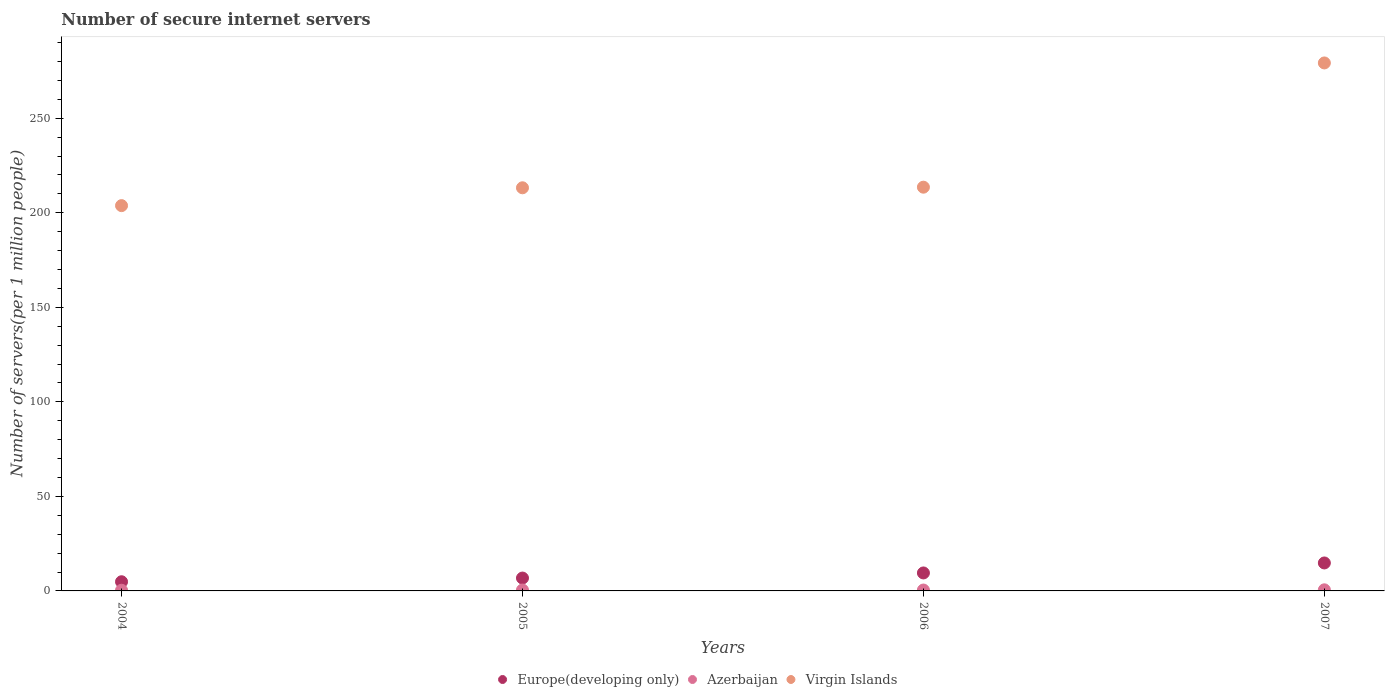How many different coloured dotlines are there?
Provide a succinct answer. 3. Is the number of dotlines equal to the number of legend labels?
Your answer should be very brief. Yes. What is the number of secure internet servers in Europe(developing only) in 2007?
Offer a very short reply. 14.79. Across all years, what is the maximum number of secure internet servers in Azerbaijan?
Keep it short and to the point. 0.58. Across all years, what is the minimum number of secure internet servers in Europe(developing only)?
Keep it short and to the point. 4.85. In which year was the number of secure internet servers in Azerbaijan minimum?
Give a very brief answer. 2004. What is the total number of secure internet servers in Virgin Islands in the graph?
Make the answer very short. 909.86. What is the difference between the number of secure internet servers in Virgin Islands in 2005 and that in 2007?
Ensure brevity in your answer.  -66.04. What is the difference between the number of secure internet servers in Europe(developing only) in 2006 and the number of secure internet servers in Virgin Islands in 2004?
Provide a succinct answer. -194.29. What is the average number of secure internet servers in Virgin Islands per year?
Your response must be concise. 227.46. In the year 2006, what is the difference between the number of secure internet servers in Azerbaijan and number of secure internet servers in Europe(developing only)?
Provide a succinct answer. -9.04. In how many years, is the number of secure internet servers in Europe(developing only) greater than 270?
Your response must be concise. 0. What is the ratio of the number of secure internet servers in Azerbaijan in 2005 to that in 2007?
Your response must be concise. 0.82. Is the number of secure internet servers in Europe(developing only) in 2004 less than that in 2007?
Make the answer very short. Yes. Is the difference between the number of secure internet servers in Azerbaijan in 2004 and 2005 greater than the difference between the number of secure internet servers in Europe(developing only) in 2004 and 2005?
Your answer should be compact. Yes. What is the difference between the highest and the second highest number of secure internet servers in Europe(developing only)?
Provide a short and direct response. 5.29. What is the difference between the highest and the lowest number of secure internet servers in Azerbaijan?
Make the answer very short. 0.22. In how many years, is the number of secure internet servers in Europe(developing only) greater than the average number of secure internet servers in Europe(developing only) taken over all years?
Offer a terse response. 2. Does the number of secure internet servers in Virgin Islands monotonically increase over the years?
Provide a succinct answer. Yes. Is the number of secure internet servers in Azerbaijan strictly greater than the number of secure internet servers in Europe(developing only) over the years?
Ensure brevity in your answer.  No. Is the number of secure internet servers in Azerbaijan strictly less than the number of secure internet servers in Virgin Islands over the years?
Make the answer very short. Yes. How many dotlines are there?
Your response must be concise. 3. Are the values on the major ticks of Y-axis written in scientific E-notation?
Your answer should be very brief. No. How are the legend labels stacked?
Ensure brevity in your answer.  Horizontal. What is the title of the graph?
Provide a succinct answer. Number of secure internet servers. What is the label or title of the Y-axis?
Make the answer very short. Number of servers(per 1 million people). What is the Number of servers(per 1 million people) in Europe(developing only) in 2004?
Your response must be concise. 4.85. What is the Number of servers(per 1 million people) of Azerbaijan in 2004?
Your response must be concise. 0.36. What is the Number of servers(per 1 million people) of Virgin Islands in 2004?
Offer a terse response. 203.8. What is the Number of servers(per 1 million people) in Europe(developing only) in 2005?
Your answer should be very brief. 6.8. What is the Number of servers(per 1 million people) of Azerbaijan in 2005?
Make the answer very short. 0.48. What is the Number of servers(per 1 million people) in Virgin Islands in 2005?
Your answer should be compact. 213.23. What is the Number of servers(per 1 million people) of Europe(developing only) in 2006?
Make the answer very short. 9.51. What is the Number of servers(per 1 million people) of Azerbaijan in 2006?
Give a very brief answer. 0.47. What is the Number of servers(per 1 million people) in Virgin Islands in 2006?
Make the answer very short. 213.56. What is the Number of servers(per 1 million people) of Europe(developing only) in 2007?
Give a very brief answer. 14.79. What is the Number of servers(per 1 million people) in Azerbaijan in 2007?
Your answer should be compact. 0.58. What is the Number of servers(per 1 million people) in Virgin Islands in 2007?
Make the answer very short. 279.27. Across all years, what is the maximum Number of servers(per 1 million people) of Europe(developing only)?
Your answer should be very brief. 14.79. Across all years, what is the maximum Number of servers(per 1 million people) of Azerbaijan?
Make the answer very short. 0.58. Across all years, what is the maximum Number of servers(per 1 million people) in Virgin Islands?
Make the answer very short. 279.27. Across all years, what is the minimum Number of servers(per 1 million people) in Europe(developing only)?
Provide a short and direct response. 4.85. Across all years, what is the minimum Number of servers(per 1 million people) in Azerbaijan?
Your response must be concise. 0.36. Across all years, what is the minimum Number of servers(per 1 million people) in Virgin Islands?
Your answer should be compact. 203.8. What is the total Number of servers(per 1 million people) of Europe(developing only) in the graph?
Make the answer very short. 35.96. What is the total Number of servers(per 1 million people) of Azerbaijan in the graph?
Your answer should be very brief. 1.89. What is the total Number of servers(per 1 million people) of Virgin Islands in the graph?
Provide a short and direct response. 909.86. What is the difference between the Number of servers(per 1 million people) of Europe(developing only) in 2004 and that in 2005?
Offer a very short reply. -1.95. What is the difference between the Number of servers(per 1 million people) in Azerbaijan in 2004 and that in 2005?
Give a very brief answer. -0.12. What is the difference between the Number of servers(per 1 million people) in Virgin Islands in 2004 and that in 2005?
Give a very brief answer. -9.44. What is the difference between the Number of servers(per 1 million people) in Europe(developing only) in 2004 and that in 2006?
Provide a short and direct response. -4.66. What is the difference between the Number of servers(per 1 million people) of Azerbaijan in 2004 and that in 2006?
Provide a succinct answer. -0.11. What is the difference between the Number of servers(per 1 million people) in Virgin Islands in 2004 and that in 2006?
Your response must be concise. -9.76. What is the difference between the Number of servers(per 1 million people) in Europe(developing only) in 2004 and that in 2007?
Offer a very short reply. -9.94. What is the difference between the Number of servers(per 1 million people) in Azerbaijan in 2004 and that in 2007?
Give a very brief answer. -0.22. What is the difference between the Number of servers(per 1 million people) of Virgin Islands in 2004 and that in 2007?
Offer a terse response. -75.47. What is the difference between the Number of servers(per 1 million people) of Europe(developing only) in 2005 and that in 2006?
Give a very brief answer. -2.7. What is the difference between the Number of servers(per 1 million people) in Azerbaijan in 2005 and that in 2006?
Make the answer very short. 0.01. What is the difference between the Number of servers(per 1 million people) of Virgin Islands in 2005 and that in 2006?
Ensure brevity in your answer.  -0.32. What is the difference between the Number of servers(per 1 million people) in Europe(developing only) in 2005 and that in 2007?
Offer a very short reply. -7.99. What is the difference between the Number of servers(per 1 million people) of Azerbaijan in 2005 and that in 2007?
Keep it short and to the point. -0.11. What is the difference between the Number of servers(per 1 million people) of Virgin Islands in 2005 and that in 2007?
Your response must be concise. -66.04. What is the difference between the Number of servers(per 1 million people) of Europe(developing only) in 2006 and that in 2007?
Your answer should be compact. -5.29. What is the difference between the Number of servers(per 1 million people) of Azerbaijan in 2006 and that in 2007?
Your answer should be very brief. -0.11. What is the difference between the Number of servers(per 1 million people) of Virgin Islands in 2006 and that in 2007?
Your response must be concise. -65.71. What is the difference between the Number of servers(per 1 million people) in Europe(developing only) in 2004 and the Number of servers(per 1 million people) in Azerbaijan in 2005?
Give a very brief answer. 4.38. What is the difference between the Number of servers(per 1 million people) in Europe(developing only) in 2004 and the Number of servers(per 1 million people) in Virgin Islands in 2005?
Offer a terse response. -208.38. What is the difference between the Number of servers(per 1 million people) in Azerbaijan in 2004 and the Number of servers(per 1 million people) in Virgin Islands in 2005?
Offer a terse response. -212.87. What is the difference between the Number of servers(per 1 million people) of Europe(developing only) in 2004 and the Number of servers(per 1 million people) of Azerbaijan in 2006?
Give a very brief answer. 4.38. What is the difference between the Number of servers(per 1 million people) of Europe(developing only) in 2004 and the Number of servers(per 1 million people) of Virgin Islands in 2006?
Your response must be concise. -208.7. What is the difference between the Number of servers(per 1 million people) of Azerbaijan in 2004 and the Number of servers(per 1 million people) of Virgin Islands in 2006?
Provide a short and direct response. -213.19. What is the difference between the Number of servers(per 1 million people) of Europe(developing only) in 2004 and the Number of servers(per 1 million people) of Azerbaijan in 2007?
Ensure brevity in your answer.  4.27. What is the difference between the Number of servers(per 1 million people) of Europe(developing only) in 2004 and the Number of servers(per 1 million people) of Virgin Islands in 2007?
Your response must be concise. -274.42. What is the difference between the Number of servers(per 1 million people) of Azerbaijan in 2004 and the Number of servers(per 1 million people) of Virgin Islands in 2007?
Your answer should be compact. -278.91. What is the difference between the Number of servers(per 1 million people) in Europe(developing only) in 2005 and the Number of servers(per 1 million people) in Azerbaijan in 2006?
Your response must be concise. 6.33. What is the difference between the Number of servers(per 1 million people) in Europe(developing only) in 2005 and the Number of servers(per 1 million people) in Virgin Islands in 2006?
Your answer should be compact. -206.75. What is the difference between the Number of servers(per 1 million people) in Azerbaijan in 2005 and the Number of servers(per 1 million people) in Virgin Islands in 2006?
Ensure brevity in your answer.  -213.08. What is the difference between the Number of servers(per 1 million people) in Europe(developing only) in 2005 and the Number of servers(per 1 million people) in Azerbaijan in 2007?
Provide a succinct answer. 6.22. What is the difference between the Number of servers(per 1 million people) of Europe(developing only) in 2005 and the Number of servers(per 1 million people) of Virgin Islands in 2007?
Give a very brief answer. -272.47. What is the difference between the Number of servers(per 1 million people) in Azerbaijan in 2005 and the Number of servers(per 1 million people) in Virgin Islands in 2007?
Give a very brief answer. -278.79. What is the difference between the Number of servers(per 1 million people) in Europe(developing only) in 2006 and the Number of servers(per 1 million people) in Azerbaijan in 2007?
Provide a succinct answer. 8.92. What is the difference between the Number of servers(per 1 million people) in Europe(developing only) in 2006 and the Number of servers(per 1 million people) in Virgin Islands in 2007?
Give a very brief answer. -269.76. What is the difference between the Number of servers(per 1 million people) in Azerbaijan in 2006 and the Number of servers(per 1 million people) in Virgin Islands in 2007?
Your response must be concise. -278.8. What is the average Number of servers(per 1 million people) of Europe(developing only) per year?
Give a very brief answer. 8.99. What is the average Number of servers(per 1 million people) in Azerbaijan per year?
Provide a short and direct response. 0.47. What is the average Number of servers(per 1 million people) in Virgin Islands per year?
Make the answer very short. 227.46. In the year 2004, what is the difference between the Number of servers(per 1 million people) in Europe(developing only) and Number of servers(per 1 million people) in Azerbaijan?
Provide a succinct answer. 4.49. In the year 2004, what is the difference between the Number of servers(per 1 million people) in Europe(developing only) and Number of servers(per 1 million people) in Virgin Islands?
Make the answer very short. -198.95. In the year 2004, what is the difference between the Number of servers(per 1 million people) of Azerbaijan and Number of servers(per 1 million people) of Virgin Islands?
Keep it short and to the point. -203.44. In the year 2005, what is the difference between the Number of servers(per 1 million people) in Europe(developing only) and Number of servers(per 1 million people) in Azerbaijan?
Provide a succinct answer. 6.33. In the year 2005, what is the difference between the Number of servers(per 1 million people) in Europe(developing only) and Number of servers(per 1 million people) in Virgin Islands?
Provide a succinct answer. -206.43. In the year 2005, what is the difference between the Number of servers(per 1 million people) in Azerbaijan and Number of servers(per 1 million people) in Virgin Islands?
Provide a short and direct response. -212.76. In the year 2006, what is the difference between the Number of servers(per 1 million people) in Europe(developing only) and Number of servers(per 1 million people) in Azerbaijan?
Offer a terse response. 9.04. In the year 2006, what is the difference between the Number of servers(per 1 million people) of Europe(developing only) and Number of servers(per 1 million people) of Virgin Islands?
Offer a terse response. -204.05. In the year 2006, what is the difference between the Number of servers(per 1 million people) of Azerbaijan and Number of servers(per 1 million people) of Virgin Islands?
Make the answer very short. -213.08. In the year 2007, what is the difference between the Number of servers(per 1 million people) in Europe(developing only) and Number of servers(per 1 million people) in Azerbaijan?
Provide a short and direct response. 14.21. In the year 2007, what is the difference between the Number of servers(per 1 million people) in Europe(developing only) and Number of servers(per 1 million people) in Virgin Islands?
Your answer should be compact. -264.48. In the year 2007, what is the difference between the Number of servers(per 1 million people) of Azerbaijan and Number of servers(per 1 million people) of Virgin Islands?
Offer a terse response. -278.69. What is the ratio of the Number of servers(per 1 million people) in Europe(developing only) in 2004 to that in 2005?
Your answer should be very brief. 0.71. What is the ratio of the Number of servers(per 1 million people) in Azerbaijan in 2004 to that in 2005?
Your response must be concise. 0.76. What is the ratio of the Number of servers(per 1 million people) of Virgin Islands in 2004 to that in 2005?
Keep it short and to the point. 0.96. What is the ratio of the Number of servers(per 1 million people) in Europe(developing only) in 2004 to that in 2006?
Your answer should be compact. 0.51. What is the ratio of the Number of servers(per 1 million people) in Azerbaijan in 2004 to that in 2006?
Offer a very short reply. 0.77. What is the ratio of the Number of servers(per 1 million people) of Virgin Islands in 2004 to that in 2006?
Provide a short and direct response. 0.95. What is the ratio of the Number of servers(per 1 million people) of Europe(developing only) in 2004 to that in 2007?
Keep it short and to the point. 0.33. What is the ratio of the Number of servers(per 1 million people) in Azerbaijan in 2004 to that in 2007?
Offer a terse response. 0.62. What is the ratio of the Number of servers(per 1 million people) in Virgin Islands in 2004 to that in 2007?
Offer a terse response. 0.73. What is the ratio of the Number of servers(per 1 million people) in Europe(developing only) in 2005 to that in 2006?
Your answer should be very brief. 0.72. What is the ratio of the Number of servers(per 1 million people) in Azerbaijan in 2005 to that in 2006?
Your response must be concise. 1.01. What is the ratio of the Number of servers(per 1 million people) of Europe(developing only) in 2005 to that in 2007?
Provide a short and direct response. 0.46. What is the ratio of the Number of servers(per 1 million people) of Azerbaijan in 2005 to that in 2007?
Keep it short and to the point. 0.82. What is the ratio of the Number of servers(per 1 million people) in Virgin Islands in 2005 to that in 2007?
Provide a succinct answer. 0.76. What is the ratio of the Number of servers(per 1 million people) of Europe(developing only) in 2006 to that in 2007?
Give a very brief answer. 0.64. What is the ratio of the Number of servers(per 1 million people) in Azerbaijan in 2006 to that in 2007?
Provide a succinct answer. 0.81. What is the ratio of the Number of servers(per 1 million people) of Virgin Islands in 2006 to that in 2007?
Make the answer very short. 0.76. What is the difference between the highest and the second highest Number of servers(per 1 million people) in Europe(developing only)?
Your answer should be very brief. 5.29. What is the difference between the highest and the second highest Number of servers(per 1 million people) in Azerbaijan?
Your response must be concise. 0.11. What is the difference between the highest and the second highest Number of servers(per 1 million people) in Virgin Islands?
Provide a short and direct response. 65.71. What is the difference between the highest and the lowest Number of servers(per 1 million people) in Europe(developing only)?
Keep it short and to the point. 9.94. What is the difference between the highest and the lowest Number of servers(per 1 million people) in Azerbaijan?
Your response must be concise. 0.22. What is the difference between the highest and the lowest Number of servers(per 1 million people) in Virgin Islands?
Make the answer very short. 75.47. 